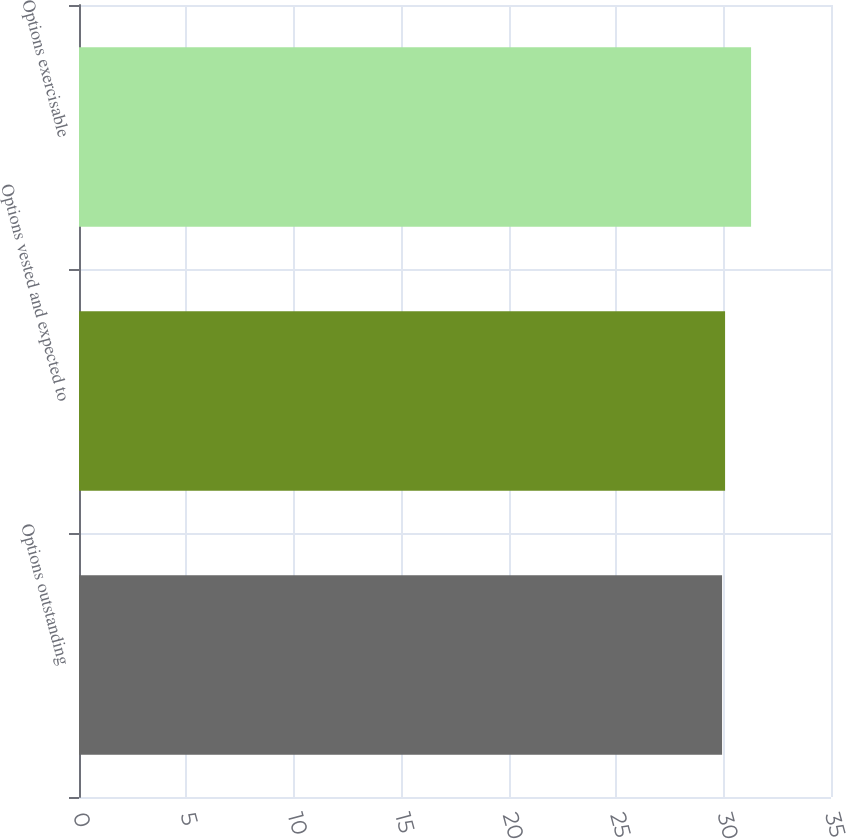<chart> <loc_0><loc_0><loc_500><loc_500><bar_chart><fcel>Options outstanding<fcel>Options vested and expected to<fcel>Options exercisable<nl><fcel>29.93<fcel>30.07<fcel>31.28<nl></chart> 